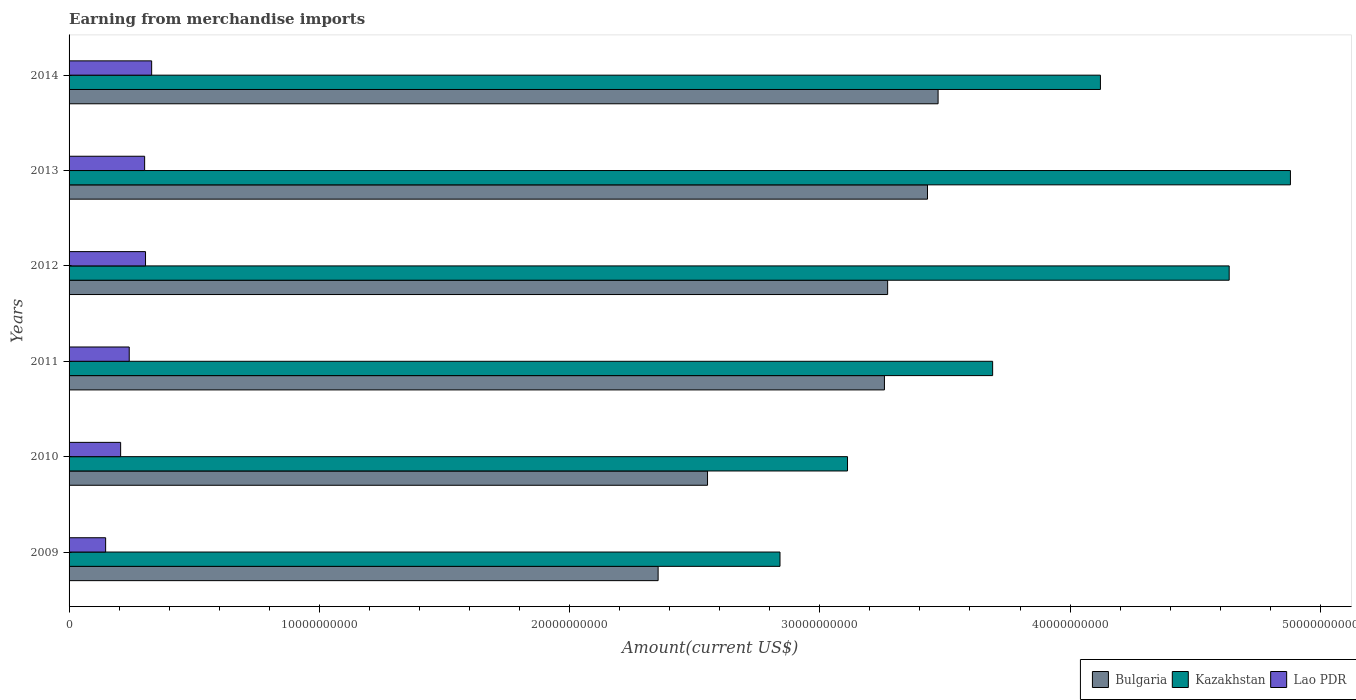Are the number of bars per tick equal to the number of legend labels?
Your response must be concise. Yes. How many bars are there on the 1st tick from the bottom?
Provide a succinct answer. 3. In how many cases, is the number of bars for a given year not equal to the number of legend labels?
Provide a succinct answer. 0. What is the amount earned from merchandise imports in Kazakhstan in 2013?
Provide a succinct answer. 4.88e+1. Across all years, what is the maximum amount earned from merchandise imports in Kazakhstan?
Ensure brevity in your answer.  4.88e+1. Across all years, what is the minimum amount earned from merchandise imports in Bulgaria?
Give a very brief answer. 2.35e+1. What is the total amount earned from merchandise imports in Kazakhstan in the graph?
Your response must be concise. 2.33e+11. What is the difference between the amount earned from merchandise imports in Lao PDR in 2013 and that in 2014?
Provide a short and direct response. -2.80e+08. What is the difference between the amount earned from merchandise imports in Bulgaria in 2009 and the amount earned from merchandise imports in Kazakhstan in 2011?
Your answer should be very brief. -1.34e+1. What is the average amount earned from merchandise imports in Kazakhstan per year?
Offer a terse response. 3.88e+1. In the year 2012, what is the difference between the amount earned from merchandise imports in Lao PDR and amount earned from merchandise imports in Kazakhstan?
Your answer should be very brief. -4.33e+1. In how many years, is the amount earned from merchandise imports in Kazakhstan greater than 10000000000 US$?
Give a very brief answer. 6. What is the ratio of the amount earned from merchandise imports in Kazakhstan in 2009 to that in 2014?
Provide a short and direct response. 0.69. Is the amount earned from merchandise imports in Bulgaria in 2009 less than that in 2014?
Your answer should be very brief. Yes. Is the difference between the amount earned from merchandise imports in Lao PDR in 2012 and 2013 greater than the difference between the amount earned from merchandise imports in Kazakhstan in 2012 and 2013?
Ensure brevity in your answer.  Yes. What is the difference between the highest and the second highest amount earned from merchandise imports in Bulgaria?
Your answer should be very brief. 4.23e+08. What is the difference between the highest and the lowest amount earned from merchandise imports in Kazakhstan?
Your answer should be very brief. 2.04e+1. What does the 2nd bar from the top in 2014 represents?
Your response must be concise. Kazakhstan. What does the 3rd bar from the bottom in 2014 represents?
Your answer should be very brief. Lao PDR. How many bars are there?
Provide a succinct answer. 18. Are all the bars in the graph horizontal?
Provide a short and direct response. Yes. What is the difference between two consecutive major ticks on the X-axis?
Give a very brief answer. 1.00e+1. Are the values on the major ticks of X-axis written in scientific E-notation?
Ensure brevity in your answer.  No. Does the graph contain grids?
Offer a very short reply. No. Where does the legend appear in the graph?
Your answer should be very brief. Bottom right. What is the title of the graph?
Offer a terse response. Earning from merchandise imports. Does "Panama" appear as one of the legend labels in the graph?
Give a very brief answer. No. What is the label or title of the X-axis?
Offer a very short reply. Amount(current US$). What is the Amount(current US$) in Bulgaria in 2009?
Offer a very short reply. 2.35e+1. What is the Amount(current US$) of Kazakhstan in 2009?
Make the answer very short. 2.84e+1. What is the Amount(current US$) of Lao PDR in 2009?
Your response must be concise. 1.46e+09. What is the Amount(current US$) in Bulgaria in 2010?
Provide a succinct answer. 2.55e+1. What is the Amount(current US$) in Kazakhstan in 2010?
Your answer should be very brief. 3.11e+1. What is the Amount(current US$) in Lao PDR in 2010?
Your response must be concise. 2.06e+09. What is the Amount(current US$) in Bulgaria in 2011?
Offer a very short reply. 3.26e+1. What is the Amount(current US$) of Kazakhstan in 2011?
Ensure brevity in your answer.  3.69e+1. What is the Amount(current US$) of Lao PDR in 2011?
Provide a succinct answer. 2.40e+09. What is the Amount(current US$) in Bulgaria in 2012?
Your response must be concise. 3.27e+1. What is the Amount(current US$) of Kazakhstan in 2012?
Offer a very short reply. 4.64e+1. What is the Amount(current US$) in Lao PDR in 2012?
Your answer should be compact. 3.06e+09. What is the Amount(current US$) of Bulgaria in 2013?
Your answer should be compact. 3.43e+1. What is the Amount(current US$) in Kazakhstan in 2013?
Make the answer very short. 4.88e+1. What is the Amount(current US$) in Lao PDR in 2013?
Your answer should be very brief. 3.02e+09. What is the Amount(current US$) of Bulgaria in 2014?
Offer a very short reply. 3.47e+1. What is the Amount(current US$) in Kazakhstan in 2014?
Give a very brief answer. 4.12e+1. What is the Amount(current US$) of Lao PDR in 2014?
Offer a very short reply. 3.30e+09. Across all years, what is the maximum Amount(current US$) of Bulgaria?
Offer a terse response. 3.47e+1. Across all years, what is the maximum Amount(current US$) in Kazakhstan?
Make the answer very short. 4.88e+1. Across all years, what is the maximum Amount(current US$) in Lao PDR?
Offer a terse response. 3.30e+09. Across all years, what is the minimum Amount(current US$) in Bulgaria?
Provide a short and direct response. 2.35e+1. Across all years, what is the minimum Amount(current US$) of Kazakhstan?
Ensure brevity in your answer.  2.84e+1. Across all years, what is the minimum Amount(current US$) in Lao PDR?
Your response must be concise. 1.46e+09. What is the total Amount(current US$) in Bulgaria in the graph?
Provide a short and direct response. 1.83e+11. What is the total Amount(current US$) in Kazakhstan in the graph?
Make the answer very short. 2.33e+11. What is the total Amount(current US$) in Lao PDR in the graph?
Offer a terse response. 1.53e+1. What is the difference between the Amount(current US$) in Bulgaria in 2009 and that in 2010?
Your response must be concise. -1.97e+09. What is the difference between the Amount(current US$) in Kazakhstan in 2009 and that in 2010?
Your answer should be compact. -2.70e+09. What is the difference between the Amount(current US$) of Lao PDR in 2009 and that in 2010?
Offer a terse response. -5.99e+08. What is the difference between the Amount(current US$) in Bulgaria in 2009 and that in 2011?
Keep it short and to the point. -9.04e+09. What is the difference between the Amount(current US$) in Kazakhstan in 2009 and that in 2011?
Keep it short and to the point. -8.50e+09. What is the difference between the Amount(current US$) of Lao PDR in 2009 and that in 2011?
Offer a terse response. -9.43e+08. What is the difference between the Amount(current US$) of Bulgaria in 2009 and that in 2012?
Your answer should be compact. -9.17e+09. What is the difference between the Amount(current US$) of Kazakhstan in 2009 and that in 2012?
Give a very brief answer. -1.79e+1. What is the difference between the Amount(current US$) of Lao PDR in 2009 and that in 2012?
Your answer should be very brief. -1.59e+09. What is the difference between the Amount(current US$) in Bulgaria in 2009 and that in 2013?
Keep it short and to the point. -1.08e+1. What is the difference between the Amount(current US$) in Kazakhstan in 2009 and that in 2013?
Give a very brief answer. -2.04e+1. What is the difference between the Amount(current US$) of Lao PDR in 2009 and that in 2013?
Offer a very short reply. -1.56e+09. What is the difference between the Amount(current US$) in Bulgaria in 2009 and that in 2014?
Keep it short and to the point. -1.12e+1. What is the difference between the Amount(current US$) in Kazakhstan in 2009 and that in 2014?
Ensure brevity in your answer.  -1.28e+1. What is the difference between the Amount(current US$) of Lao PDR in 2009 and that in 2014?
Offer a terse response. -1.84e+09. What is the difference between the Amount(current US$) in Bulgaria in 2010 and that in 2011?
Your answer should be compact. -7.07e+09. What is the difference between the Amount(current US$) in Kazakhstan in 2010 and that in 2011?
Provide a succinct answer. -5.80e+09. What is the difference between the Amount(current US$) in Lao PDR in 2010 and that in 2011?
Keep it short and to the point. -3.44e+08. What is the difference between the Amount(current US$) in Bulgaria in 2010 and that in 2012?
Your response must be concise. -7.20e+09. What is the difference between the Amount(current US$) in Kazakhstan in 2010 and that in 2012?
Your answer should be very brief. -1.53e+1. What is the difference between the Amount(current US$) of Lao PDR in 2010 and that in 2012?
Your answer should be compact. -9.95e+08. What is the difference between the Amount(current US$) in Bulgaria in 2010 and that in 2013?
Your answer should be compact. -8.79e+09. What is the difference between the Amount(current US$) of Kazakhstan in 2010 and that in 2013?
Keep it short and to the point. -1.77e+1. What is the difference between the Amount(current US$) in Lao PDR in 2010 and that in 2013?
Give a very brief answer. -9.59e+08. What is the difference between the Amount(current US$) of Bulgaria in 2010 and that in 2014?
Your answer should be very brief. -9.21e+09. What is the difference between the Amount(current US$) in Kazakhstan in 2010 and that in 2014?
Keep it short and to the point. -1.01e+1. What is the difference between the Amount(current US$) in Lao PDR in 2010 and that in 2014?
Provide a short and direct response. -1.24e+09. What is the difference between the Amount(current US$) of Bulgaria in 2011 and that in 2012?
Offer a very short reply. -1.29e+08. What is the difference between the Amount(current US$) in Kazakhstan in 2011 and that in 2012?
Offer a very short reply. -9.45e+09. What is the difference between the Amount(current US$) in Lao PDR in 2011 and that in 2012?
Ensure brevity in your answer.  -6.51e+08. What is the difference between the Amount(current US$) of Bulgaria in 2011 and that in 2013?
Provide a short and direct response. -1.72e+09. What is the difference between the Amount(current US$) in Kazakhstan in 2011 and that in 2013?
Provide a short and direct response. -1.19e+1. What is the difference between the Amount(current US$) in Lao PDR in 2011 and that in 2013?
Offer a terse response. -6.15e+08. What is the difference between the Amount(current US$) in Bulgaria in 2011 and that in 2014?
Your answer should be very brief. -2.14e+09. What is the difference between the Amount(current US$) of Kazakhstan in 2011 and that in 2014?
Provide a short and direct response. -4.31e+09. What is the difference between the Amount(current US$) in Lao PDR in 2011 and that in 2014?
Keep it short and to the point. -8.96e+08. What is the difference between the Amount(current US$) of Bulgaria in 2012 and that in 2013?
Keep it short and to the point. -1.59e+09. What is the difference between the Amount(current US$) in Kazakhstan in 2012 and that in 2013?
Make the answer very short. -2.45e+09. What is the difference between the Amount(current US$) in Lao PDR in 2012 and that in 2013?
Offer a terse response. 3.54e+07. What is the difference between the Amount(current US$) in Bulgaria in 2012 and that in 2014?
Make the answer very short. -2.02e+09. What is the difference between the Amount(current US$) in Kazakhstan in 2012 and that in 2014?
Your answer should be very brief. 5.15e+09. What is the difference between the Amount(current US$) of Lao PDR in 2012 and that in 2014?
Ensure brevity in your answer.  -2.45e+08. What is the difference between the Amount(current US$) in Bulgaria in 2013 and that in 2014?
Your answer should be very brief. -4.23e+08. What is the difference between the Amount(current US$) of Kazakhstan in 2013 and that in 2014?
Ensure brevity in your answer.  7.59e+09. What is the difference between the Amount(current US$) of Lao PDR in 2013 and that in 2014?
Your answer should be compact. -2.80e+08. What is the difference between the Amount(current US$) in Bulgaria in 2009 and the Amount(current US$) in Kazakhstan in 2010?
Your response must be concise. -7.57e+09. What is the difference between the Amount(current US$) in Bulgaria in 2009 and the Amount(current US$) in Lao PDR in 2010?
Offer a terse response. 2.15e+1. What is the difference between the Amount(current US$) in Kazakhstan in 2009 and the Amount(current US$) in Lao PDR in 2010?
Offer a terse response. 2.63e+1. What is the difference between the Amount(current US$) in Bulgaria in 2009 and the Amount(current US$) in Kazakhstan in 2011?
Your response must be concise. -1.34e+1. What is the difference between the Amount(current US$) of Bulgaria in 2009 and the Amount(current US$) of Lao PDR in 2011?
Ensure brevity in your answer.  2.11e+1. What is the difference between the Amount(current US$) in Kazakhstan in 2009 and the Amount(current US$) in Lao PDR in 2011?
Keep it short and to the point. 2.60e+1. What is the difference between the Amount(current US$) in Bulgaria in 2009 and the Amount(current US$) in Kazakhstan in 2012?
Keep it short and to the point. -2.28e+1. What is the difference between the Amount(current US$) in Bulgaria in 2009 and the Amount(current US$) in Lao PDR in 2012?
Give a very brief answer. 2.05e+1. What is the difference between the Amount(current US$) of Kazakhstan in 2009 and the Amount(current US$) of Lao PDR in 2012?
Offer a terse response. 2.54e+1. What is the difference between the Amount(current US$) of Bulgaria in 2009 and the Amount(current US$) of Kazakhstan in 2013?
Your answer should be compact. -2.53e+1. What is the difference between the Amount(current US$) in Bulgaria in 2009 and the Amount(current US$) in Lao PDR in 2013?
Provide a succinct answer. 2.05e+1. What is the difference between the Amount(current US$) of Kazakhstan in 2009 and the Amount(current US$) of Lao PDR in 2013?
Give a very brief answer. 2.54e+1. What is the difference between the Amount(current US$) of Bulgaria in 2009 and the Amount(current US$) of Kazakhstan in 2014?
Make the answer very short. -1.77e+1. What is the difference between the Amount(current US$) in Bulgaria in 2009 and the Amount(current US$) in Lao PDR in 2014?
Offer a very short reply. 2.02e+1. What is the difference between the Amount(current US$) of Kazakhstan in 2009 and the Amount(current US$) of Lao PDR in 2014?
Provide a succinct answer. 2.51e+1. What is the difference between the Amount(current US$) of Bulgaria in 2010 and the Amount(current US$) of Kazakhstan in 2011?
Keep it short and to the point. -1.14e+1. What is the difference between the Amount(current US$) of Bulgaria in 2010 and the Amount(current US$) of Lao PDR in 2011?
Provide a succinct answer. 2.31e+1. What is the difference between the Amount(current US$) in Kazakhstan in 2010 and the Amount(current US$) in Lao PDR in 2011?
Your answer should be compact. 2.87e+1. What is the difference between the Amount(current US$) in Bulgaria in 2010 and the Amount(current US$) in Kazakhstan in 2012?
Your answer should be very brief. -2.08e+1. What is the difference between the Amount(current US$) of Bulgaria in 2010 and the Amount(current US$) of Lao PDR in 2012?
Your answer should be very brief. 2.25e+1. What is the difference between the Amount(current US$) of Kazakhstan in 2010 and the Amount(current US$) of Lao PDR in 2012?
Offer a terse response. 2.81e+1. What is the difference between the Amount(current US$) of Bulgaria in 2010 and the Amount(current US$) of Kazakhstan in 2013?
Keep it short and to the point. -2.33e+1. What is the difference between the Amount(current US$) of Bulgaria in 2010 and the Amount(current US$) of Lao PDR in 2013?
Your answer should be compact. 2.25e+1. What is the difference between the Amount(current US$) in Kazakhstan in 2010 and the Amount(current US$) in Lao PDR in 2013?
Provide a short and direct response. 2.81e+1. What is the difference between the Amount(current US$) of Bulgaria in 2010 and the Amount(current US$) of Kazakhstan in 2014?
Offer a terse response. -1.57e+1. What is the difference between the Amount(current US$) in Bulgaria in 2010 and the Amount(current US$) in Lao PDR in 2014?
Ensure brevity in your answer.  2.22e+1. What is the difference between the Amount(current US$) of Kazakhstan in 2010 and the Amount(current US$) of Lao PDR in 2014?
Your response must be concise. 2.78e+1. What is the difference between the Amount(current US$) of Bulgaria in 2011 and the Amount(current US$) of Kazakhstan in 2012?
Provide a short and direct response. -1.38e+1. What is the difference between the Amount(current US$) of Bulgaria in 2011 and the Amount(current US$) of Lao PDR in 2012?
Provide a short and direct response. 2.95e+1. What is the difference between the Amount(current US$) of Kazakhstan in 2011 and the Amount(current US$) of Lao PDR in 2012?
Give a very brief answer. 3.39e+1. What is the difference between the Amount(current US$) of Bulgaria in 2011 and the Amount(current US$) of Kazakhstan in 2013?
Offer a very short reply. -1.62e+1. What is the difference between the Amount(current US$) in Bulgaria in 2011 and the Amount(current US$) in Lao PDR in 2013?
Make the answer very short. 2.96e+1. What is the difference between the Amount(current US$) in Kazakhstan in 2011 and the Amount(current US$) in Lao PDR in 2013?
Your response must be concise. 3.39e+1. What is the difference between the Amount(current US$) in Bulgaria in 2011 and the Amount(current US$) in Kazakhstan in 2014?
Make the answer very short. -8.63e+09. What is the difference between the Amount(current US$) of Bulgaria in 2011 and the Amount(current US$) of Lao PDR in 2014?
Keep it short and to the point. 2.93e+1. What is the difference between the Amount(current US$) in Kazakhstan in 2011 and the Amount(current US$) in Lao PDR in 2014?
Your response must be concise. 3.36e+1. What is the difference between the Amount(current US$) of Bulgaria in 2012 and the Amount(current US$) of Kazakhstan in 2013?
Make the answer very short. -1.61e+1. What is the difference between the Amount(current US$) in Bulgaria in 2012 and the Amount(current US$) in Lao PDR in 2013?
Your answer should be very brief. 2.97e+1. What is the difference between the Amount(current US$) in Kazakhstan in 2012 and the Amount(current US$) in Lao PDR in 2013?
Keep it short and to the point. 4.33e+1. What is the difference between the Amount(current US$) of Bulgaria in 2012 and the Amount(current US$) of Kazakhstan in 2014?
Your answer should be very brief. -8.50e+09. What is the difference between the Amount(current US$) of Bulgaria in 2012 and the Amount(current US$) of Lao PDR in 2014?
Make the answer very short. 2.94e+1. What is the difference between the Amount(current US$) of Kazakhstan in 2012 and the Amount(current US$) of Lao PDR in 2014?
Keep it short and to the point. 4.31e+1. What is the difference between the Amount(current US$) in Bulgaria in 2013 and the Amount(current US$) in Kazakhstan in 2014?
Your answer should be compact. -6.91e+09. What is the difference between the Amount(current US$) in Bulgaria in 2013 and the Amount(current US$) in Lao PDR in 2014?
Your answer should be compact. 3.10e+1. What is the difference between the Amount(current US$) of Kazakhstan in 2013 and the Amount(current US$) of Lao PDR in 2014?
Offer a very short reply. 4.55e+1. What is the average Amount(current US$) of Bulgaria per year?
Your answer should be very brief. 3.06e+1. What is the average Amount(current US$) of Kazakhstan per year?
Offer a terse response. 3.88e+1. What is the average Amount(current US$) in Lao PDR per year?
Ensure brevity in your answer.  2.55e+09. In the year 2009, what is the difference between the Amount(current US$) in Bulgaria and Amount(current US$) in Kazakhstan?
Offer a terse response. -4.87e+09. In the year 2009, what is the difference between the Amount(current US$) in Bulgaria and Amount(current US$) in Lao PDR?
Ensure brevity in your answer.  2.21e+1. In the year 2009, what is the difference between the Amount(current US$) in Kazakhstan and Amount(current US$) in Lao PDR?
Offer a terse response. 2.69e+1. In the year 2010, what is the difference between the Amount(current US$) in Bulgaria and Amount(current US$) in Kazakhstan?
Your answer should be very brief. -5.59e+09. In the year 2010, what is the difference between the Amount(current US$) of Bulgaria and Amount(current US$) of Lao PDR?
Keep it short and to the point. 2.35e+1. In the year 2010, what is the difference between the Amount(current US$) of Kazakhstan and Amount(current US$) of Lao PDR?
Your response must be concise. 2.90e+1. In the year 2011, what is the difference between the Amount(current US$) in Bulgaria and Amount(current US$) in Kazakhstan?
Give a very brief answer. -4.32e+09. In the year 2011, what is the difference between the Amount(current US$) of Bulgaria and Amount(current US$) of Lao PDR?
Your response must be concise. 3.02e+1. In the year 2011, what is the difference between the Amount(current US$) of Kazakhstan and Amount(current US$) of Lao PDR?
Ensure brevity in your answer.  3.45e+1. In the year 2012, what is the difference between the Amount(current US$) in Bulgaria and Amount(current US$) in Kazakhstan?
Your answer should be very brief. -1.36e+1. In the year 2012, what is the difference between the Amount(current US$) in Bulgaria and Amount(current US$) in Lao PDR?
Provide a short and direct response. 2.97e+1. In the year 2012, what is the difference between the Amount(current US$) in Kazakhstan and Amount(current US$) in Lao PDR?
Your response must be concise. 4.33e+1. In the year 2013, what is the difference between the Amount(current US$) of Bulgaria and Amount(current US$) of Kazakhstan?
Offer a terse response. -1.45e+1. In the year 2013, what is the difference between the Amount(current US$) of Bulgaria and Amount(current US$) of Lao PDR?
Keep it short and to the point. 3.13e+1. In the year 2013, what is the difference between the Amount(current US$) in Kazakhstan and Amount(current US$) in Lao PDR?
Provide a short and direct response. 4.58e+1. In the year 2014, what is the difference between the Amount(current US$) in Bulgaria and Amount(current US$) in Kazakhstan?
Your response must be concise. -6.49e+09. In the year 2014, what is the difference between the Amount(current US$) of Bulgaria and Amount(current US$) of Lao PDR?
Keep it short and to the point. 3.14e+1. In the year 2014, what is the difference between the Amount(current US$) in Kazakhstan and Amount(current US$) in Lao PDR?
Offer a terse response. 3.79e+1. What is the ratio of the Amount(current US$) in Bulgaria in 2009 to that in 2010?
Your answer should be compact. 0.92. What is the ratio of the Amount(current US$) in Kazakhstan in 2009 to that in 2010?
Ensure brevity in your answer.  0.91. What is the ratio of the Amount(current US$) in Lao PDR in 2009 to that in 2010?
Make the answer very short. 0.71. What is the ratio of the Amount(current US$) of Bulgaria in 2009 to that in 2011?
Keep it short and to the point. 0.72. What is the ratio of the Amount(current US$) in Kazakhstan in 2009 to that in 2011?
Your response must be concise. 0.77. What is the ratio of the Amount(current US$) in Lao PDR in 2009 to that in 2011?
Provide a succinct answer. 0.61. What is the ratio of the Amount(current US$) in Bulgaria in 2009 to that in 2012?
Offer a terse response. 0.72. What is the ratio of the Amount(current US$) in Kazakhstan in 2009 to that in 2012?
Provide a succinct answer. 0.61. What is the ratio of the Amount(current US$) in Lao PDR in 2009 to that in 2012?
Provide a short and direct response. 0.48. What is the ratio of the Amount(current US$) of Bulgaria in 2009 to that in 2013?
Your answer should be compact. 0.69. What is the ratio of the Amount(current US$) in Kazakhstan in 2009 to that in 2013?
Your answer should be compact. 0.58. What is the ratio of the Amount(current US$) of Lao PDR in 2009 to that in 2013?
Your answer should be very brief. 0.48. What is the ratio of the Amount(current US$) in Bulgaria in 2009 to that in 2014?
Keep it short and to the point. 0.68. What is the ratio of the Amount(current US$) of Kazakhstan in 2009 to that in 2014?
Provide a succinct answer. 0.69. What is the ratio of the Amount(current US$) in Lao PDR in 2009 to that in 2014?
Offer a terse response. 0.44. What is the ratio of the Amount(current US$) in Bulgaria in 2010 to that in 2011?
Your answer should be compact. 0.78. What is the ratio of the Amount(current US$) in Kazakhstan in 2010 to that in 2011?
Your answer should be compact. 0.84. What is the ratio of the Amount(current US$) of Lao PDR in 2010 to that in 2011?
Offer a terse response. 0.86. What is the ratio of the Amount(current US$) of Bulgaria in 2010 to that in 2012?
Offer a very short reply. 0.78. What is the ratio of the Amount(current US$) of Kazakhstan in 2010 to that in 2012?
Your answer should be very brief. 0.67. What is the ratio of the Amount(current US$) of Lao PDR in 2010 to that in 2012?
Your response must be concise. 0.67. What is the ratio of the Amount(current US$) in Bulgaria in 2010 to that in 2013?
Provide a short and direct response. 0.74. What is the ratio of the Amount(current US$) in Kazakhstan in 2010 to that in 2013?
Make the answer very short. 0.64. What is the ratio of the Amount(current US$) in Lao PDR in 2010 to that in 2013?
Give a very brief answer. 0.68. What is the ratio of the Amount(current US$) of Bulgaria in 2010 to that in 2014?
Your response must be concise. 0.73. What is the ratio of the Amount(current US$) in Kazakhstan in 2010 to that in 2014?
Provide a short and direct response. 0.75. What is the ratio of the Amount(current US$) in Lao PDR in 2010 to that in 2014?
Offer a very short reply. 0.62. What is the ratio of the Amount(current US$) of Bulgaria in 2011 to that in 2012?
Offer a terse response. 1. What is the ratio of the Amount(current US$) of Kazakhstan in 2011 to that in 2012?
Ensure brevity in your answer.  0.8. What is the ratio of the Amount(current US$) of Lao PDR in 2011 to that in 2012?
Your answer should be very brief. 0.79. What is the ratio of the Amount(current US$) of Bulgaria in 2011 to that in 2013?
Keep it short and to the point. 0.95. What is the ratio of the Amount(current US$) in Kazakhstan in 2011 to that in 2013?
Provide a succinct answer. 0.76. What is the ratio of the Amount(current US$) of Lao PDR in 2011 to that in 2013?
Make the answer very short. 0.8. What is the ratio of the Amount(current US$) in Bulgaria in 2011 to that in 2014?
Make the answer very short. 0.94. What is the ratio of the Amount(current US$) of Kazakhstan in 2011 to that in 2014?
Give a very brief answer. 0.9. What is the ratio of the Amount(current US$) of Lao PDR in 2011 to that in 2014?
Your answer should be compact. 0.73. What is the ratio of the Amount(current US$) in Bulgaria in 2012 to that in 2013?
Your answer should be compact. 0.95. What is the ratio of the Amount(current US$) of Kazakhstan in 2012 to that in 2013?
Your answer should be very brief. 0.95. What is the ratio of the Amount(current US$) of Lao PDR in 2012 to that in 2013?
Offer a very short reply. 1.01. What is the ratio of the Amount(current US$) of Bulgaria in 2012 to that in 2014?
Provide a short and direct response. 0.94. What is the ratio of the Amount(current US$) of Kazakhstan in 2012 to that in 2014?
Your answer should be compact. 1.12. What is the ratio of the Amount(current US$) of Lao PDR in 2012 to that in 2014?
Make the answer very short. 0.93. What is the ratio of the Amount(current US$) in Bulgaria in 2013 to that in 2014?
Make the answer very short. 0.99. What is the ratio of the Amount(current US$) in Kazakhstan in 2013 to that in 2014?
Your answer should be compact. 1.18. What is the ratio of the Amount(current US$) of Lao PDR in 2013 to that in 2014?
Provide a succinct answer. 0.92. What is the difference between the highest and the second highest Amount(current US$) in Bulgaria?
Keep it short and to the point. 4.23e+08. What is the difference between the highest and the second highest Amount(current US$) in Kazakhstan?
Offer a terse response. 2.45e+09. What is the difference between the highest and the second highest Amount(current US$) in Lao PDR?
Ensure brevity in your answer.  2.45e+08. What is the difference between the highest and the lowest Amount(current US$) in Bulgaria?
Make the answer very short. 1.12e+1. What is the difference between the highest and the lowest Amount(current US$) in Kazakhstan?
Offer a very short reply. 2.04e+1. What is the difference between the highest and the lowest Amount(current US$) of Lao PDR?
Make the answer very short. 1.84e+09. 